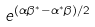<formula> <loc_0><loc_0><loc_500><loc_500>e ^ { ( \alpha \beta ^ { * } - \alpha ^ { * } \beta ) / 2 }</formula> 